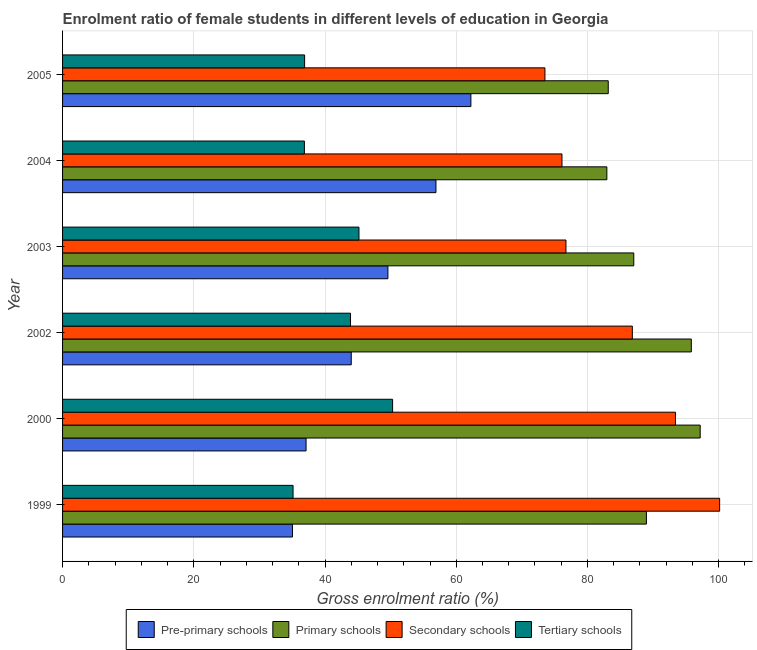How many different coloured bars are there?
Keep it short and to the point. 4. Are the number of bars per tick equal to the number of legend labels?
Make the answer very short. Yes. Are the number of bars on each tick of the Y-axis equal?
Make the answer very short. Yes. How many bars are there on the 4th tick from the top?
Give a very brief answer. 4. How many bars are there on the 3rd tick from the bottom?
Your response must be concise. 4. What is the label of the 2nd group of bars from the top?
Provide a short and direct response. 2004. In how many cases, is the number of bars for a given year not equal to the number of legend labels?
Keep it short and to the point. 0. What is the gross enrolment ratio(male) in pre-primary schools in 2004?
Make the answer very short. 56.91. Across all years, what is the maximum gross enrolment ratio(male) in tertiary schools?
Make the answer very short. 50.3. Across all years, what is the minimum gross enrolment ratio(male) in pre-primary schools?
Ensure brevity in your answer.  35.04. In which year was the gross enrolment ratio(male) in tertiary schools minimum?
Your response must be concise. 1999. What is the total gross enrolment ratio(male) in pre-primary schools in the graph?
Offer a very short reply. 284.87. What is the difference between the gross enrolment ratio(male) in primary schools in 2004 and that in 2005?
Your response must be concise. -0.21. What is the difference between the gross enrolment ratio(male) in primary schools in 2002 and the gross enrolment ratio(male) in tertiary schools in 2004?
Provide a succinct answer. 58.97. What is the average gross enrolment ratio(male) in tertiary schools per year?
Your response must be concise. 41.37. In the year 1999, what is the difference between the gross enrolment ratio(male) in secondary schools and gross enrolment ratio(male) in primary schools?
Keep it short and to the point. 11.16. What is the ratio of the gross enrolment ratio(male) in pre-primary schools in 1999 to that in 2003?
Offer a very short reply. 0.71. Is the gross enrolment ratio(male) in tertiary schools in 1999 less than that in 2004?
Make the answer very short. Yes. Is the difference between the gross enrolment ratio(male) in pre-primary schools in 2002 and 2003 greater than the difference between the gross enrolment ratio(male) in tertiary schools in 2002 and 2003?
Give a very brief answer. No. What is the difference between the highest and the second highest gross enrolment ratio(male) in primary schools?
Ensure brevity in your answer.  1.35. What is the difference between the highest and the lowest gross enrolment ratio(male) in secondary schools?
Your answer should be very brief. 26.63. In how many years, is the gross enrolment ratio(male) in pre-primary schools greater than the average gross enrolment ratio(male) in pre-primary schools taken over all years?
Offer a terse response. 3. Is the sum of the gross enrolment ratio(male) in pre-primary schools in 2002 and 2004 greater than the maximum gross enrolment ratio(male) in tertiary schools across all years?
Your answer should be very brief. Yes. Is it the case that in every year, the sum of the gross enrolment ratio(male) in pre-primary schools and gross enrolment ratio(male) in secondary schools is greater than the sum of gross enrolment ratio(male) in tertiary schools and gross enrolment ratio(male) in primary schools?
Offer a terse response. Yes. What does the 3rd bar from the top in 2003 represents?
Give a very brief answer. Primary schools. What does the 2nd bar from the bottom in 2004 represents?
Offer a terse response. Primary schools. Is it the case that in every year, the sum of the gross enrolment ratio(male) in pre-primary schools and gross enrolment ratio(male) in primary schools is greater than the gross enrolment ratio(male) in secondary schools?
Your answer should be very brief. Yes. Does the graph contain grids?
Make the answer very short. Yes. How many legend labels are there?
Keep it short and to the point. 4. How are the legend labels stacked?
Keep it short and to the point. Horizontal. What is the title of the graph?
Provide a short and direct response. Enrolment ratio of female students in different levels of education in Georgia. Does "Services" appear as one of the legend labels in the graph?
Ensure brevity in your answer.  No. What is the label or title of the Y-axis?
Make the answer very short. Year. What is the Gross enrolment ratio (%) in Pre-primary schools in 1999?
Provide a succinct answer. 35.04. What is the Gross enrolment ratio (%) in Primary schools in 1999?
Offer a terse response. 88.98. What is the Gross enrolment ratio (%) of Secondary schools in 1999?
Provide a short and direct response. 100.14. What is the Gross enrolment ratio (%) in Tertiary schools in 1999?
Offer a terse response. 35.13. What is the Gross enrolment ratio (%) of Pre-primary schools in 2000?
Provide a short and direct response. 37.11. What is the Gross enrolment ratio (%) of Primary schools in 2000?
Provide a short and direct response. 97.18. What is the Gross enrolment ratio (%) in Secondary schools in 2000?
Offer a very short reply. 93.41. What is the Gross enrolment ratio (%) of Tertiary schools in 2000?
Your response must be concise. 50.3. What is the Gross enrolment ratio (%) in Pre-primary schools in 2002?
Your response must be concise. 44. What is the Gross enrolment ratio (%) in Primary schools in 2002?
Your response must be concise. 95.83. What is the Gross enrolment ratio (%) of Secondary schools in 2002?
Make the answer very short. 86.84. What is the Gross enrolment ratio (%) of Tertiary schools in 2002?
Your answer should be very brief. 43.88. What is the Gross enrolment ratio (%) in Pre-primary schools in 2003?
Keep it short and to the point. 49.58. What is the Gross enrolment ratio (%) in Primary schools in 2003?
Offer a terse response. 87.06. What is the Gross enrolment ratio (%) of Secondary schools in 2003?
Your answer should be compact. 76.72. What is the Gross enrolment ratio (%) in Tertiary schools in 2003?
Offer a very short reply. 45.17. What is the Gross enrolment ratio (%) in Pre-primary schools in 2004?
Make the answer very short. 56.91. What is the Gross enrolment ratio (%) in Primary schools in 2004?
Provide a succinct answer. 82.95. What is the Gross enrolment ratio (%) in Secondary schools in 2004?
Make the answer very short. 76.11. What is the Gross enrolment ratio (%) in Tertiary schools in 2004?
Your answer should be very brief. 36.86. What is the Gross enrolment ratio (%) in Pre-primary schools in 2005?
Your answer should be very brief. 62.23. What is the Gross enrolment ratio (%) of Primary schools in 2005?
Make the answer very short. 83.17. What is the Gross enrolment ratio (%) of Secondary schools in 2005?
Offer a very short reply. 73.52. What is the Gross enrolment ratio (%) in Tertiary schools in 2005?
Your response must be concise. 36.89. Across all years, what is the maximum Gross enrolment ratio (%) in Pre-primary schools?
Offer a very short reply. 62.23. Across all years, what is the maximum Gross enrolment ratio (%) of Primary schools?
Provide a succinct answer. 97.18. Across all years, what is the maximum Gross enrolment ratio (%) of Secondary schools?
Keep it short and to the point. 100.14. Across all years, what is the maximum Gross enrolment ratio (%) of Tertiary schools?
Provide a succinct answer. 50.3. Across all years, what is the minimum Gross enrolment ratio (%) of Pre-primary schools?
Keep it short and to the point. 35.04. Across all years, what is the minimum Gross enrolment ratio (%) of Primary schools?
Make the answer very short. 82.95. Across all years, what is the minimum Gross enrolment ratio (%) in Secondary schools?
Provide a short and direct response. 73.52. Across all years, what is the minimum Gross enrolment ratio (%) of Tertiary schools?
Offer a very short reply. 35.13. What is the total Gross enrolment ratio (%) of Pre-primary schools in the graph?
Your response must be concise. 284.87. What is the total Gross enrolment ratio (%) of Primary schools in the graph?
Your answer should be very brief. 535.16. What is the total Gross enrolment ratio (%) in Secondary schools in the graph?
Your answer should be very brief. 506.74. What is the total Gross enrolment ratio (%) of Tertiary schools in the graph?
Keep it short and to the point. 248.23. What is the difference between the Gross enrolment ratio (%) in Pre-primary schools in 1999 and that in 2000?
Ensure brevity in your answer.  -2.07. What is the difference between the Gross enrolment ratio (%) in Primary schools in 1999 and that in 2000?
Ensure brevity in your answer.  -8.2. What is the difference between the Gross enrolment ratio (%) of Secondary schools in 1999 and that in 2000?
Offer a terse response. 6.73. What is the difference between the Gross enrolment ratio (%) in Tertiary schools in 1999 and that in 2000?
Offer a terse response. -15.17. What is the difference between the Gross enrolment ratio (%) in Pre-primary schools in 1999 and that in 2002?
Keep it short and to the point. -8.96. What is the difference between the Gross enrolment ratio (%) in Primary schools in 1999 and that in 2002?
Provide a short and direct response. -6.84. What is the difference between the Gross enrolment ratio (%) in Secondary schools in 1999 and that in 2002?
Offer a terse response. 13.3. What is the difference between the Gross enrolment ratio (%) of Tertiary schools in 1999 and that in 2002?
Your answer should be compact. -8.76. What is the difference between the Gross enrolment ratio (%) in Pre-primary schools in 1999 and that in 2003?
Your answer should be very brief. -14.55. What is the difference between the Gross enrolment ratio (%) in Primary schools in 1999 and that in 2003?
Provide a succinct answer. 1.92. What is the difference between the Gross enrolment ratio (%) of Secondary schools in 1999 and that in 2003?
Make the answer very short. 23.42. What is the difference between the Gross enrolment ratio (%) in Tertiary schools in 1999 and that in 2003?
Your answer should be very brief. -10.04. What is the difference between the Gross enrolment ratio (%) of Pre-primary schools in 1999 and that in 2004?
Provide a succinct answer. -21.87. What is the difference between the Gross enrolment ratio (%) of Primary schools in 1999 and that in 2004?
Your answer should be compact. 6.03. What is the difference between the Gross enrolment ratio (%) in Secondary schools in 1999 and that in 2004?
Provide a succinct answer. 24.03. What is the difference between the Gross enrolment ratio (%) of Tertiary schools in 1999 and that in 2004?
Ensure brevity in your answer.  -1.73. What is the difference between the Gross enrolment ratio (%) in Pre-primary schools in 1999 and that in 2005?
Ensure brevity in your answer.  -27.19. What is the difference between the Gross enrolment ratio (%) of Primary schools in 1999 and that in 2005?
Your answer should be compact. 5.82. What is the difference between the Gross enrolment ratio (%) in Secondary schools in 1999 and that in 2005?
Make the answer very short. 26.63. What is the difference between the Gross enrolment ratio (%) of Tertiary schools in 1999 and that in 2005?
Provide a short and direct response. -1.76. What is the difference between the Gross enrolment ratio (%) in Pre-primary schools in 2000 and that in 2002?
Provide a succinct answer. -6.89. What is the difference between the Gross enrolment ratio (%) in Primary schools in 2000 and that in 2002?
Give a very brief answer. 1.35. What is the difference between the Gross enrolment ratio (%) in Secondary schools in 2000 and that in 2002?
Offer a terse response. 6.57. What is the difference between the Gross enrolment ratio (%) in Tertiary schools in 2000 and that in 2002?
Your answer should be very brief. 6.41. What is the difference between the Gross enrolment ratio (%) of Pre-primary schools in 2000 and that in 2003?
Your answer should be very brief. -12.47. What is the difference between the Gross enrolment ratio (%) in Primary schools in 2000 and that in 2003?
Offer a very short reply. 10.12. What is the difference between the Gross enrolment ratio (%) of Secondary schools in 2000 and that in 2003?
Give a very brief answer. 16.69. What is the difference between the Gross enrolment ratio (%) of Tertiary schools in 2000 and that in 2003?
Provide a succinct answer. 5.12. What is the difference between the Gross enrolment ratio (%) of Pre-primary schools in 2000 and that in 2004?
Ensure brevity in your answer.  -19.8. What is the difference between the Gross enrolment ratio (%) in Primary schools in 2000 and that in 2004?
Make the answer very short. 14.22. What is the difference between the Gross enrolment ratio (%) in Secondary schools in 2000 and that in 2004?
Your response must be concise. 17.3. What is the difference between the Gross enrolment ratio (%) in Tertiary schools in 2000 and that in 2004?
Offer a terse response. 13.44. What is the difference between the Gross enrolment ratio (%) of Pre-primary schools in 2000 and that in 2005?
Offer a very short reply. -25.12. What is the difference between the Gross enrolment ratio (%) in Primary schools in 2000 and that in 2005?
Make the answer very short. 14.01. What is the difference between the Gross enrolment ratio (%) of Secondary schools in 2000 and that in 2005?
Keep it short and to the point. 19.89. What is the difference between the Gross enrolment ratio (%) in Tertiary schools in 2000 and that in 2005?
Offer a very short reply. 13.41. What is the difference between the Gross enrolment ratio (%) of Pre-primary schools in 2002 and that in 2003?
Your answer should be compact. -5.59. What is the difference between the Gross enrolment ratio (%) of Primary schools in 2002 and that in 2003?
Provide a succinct answer. 8.77. What is the difference between the Gross enrolment ratio (%) in Secondary schools in 2002 and that in 2003?
Ensure brevity in your answer.  10.12. What is the difference between the Gross enrolment ratio (%) of Tertiary schools in 2002 and that in 2003?
Provide a short and direct response. -1.29. What is the difference between the Gross enrolment ratio (%) in Pre-primary schools in 2002 and that in 2004?
Your answer should be compact. -12.91. What is the difference between the Gross enrolment ratio (%) in Primary schools in 2002 and that in 2004?
Offer a very short reply. 12.87. What is the difference between the Gross enrolment ratio (%) in Secondary schools in 2002 and that in 2004?
Offer a terse response. 10.73. What is the difference between the Gross enrolment ratio (%) of Tertiary schools in 2002 and that in 2004?
Offer a very short reply. 7.03. What is the difference between the Gross enrolment ratio (%) in Pre-primary schools in 2002 and that in 2005?
Your answer should be compact. -18.24. What is the difference between the Gross enrolment ratio (%) of Primary schools in 2002 and that in 2005?
Make the answer very short. 12.66. What is the difference between the Gross enrolment ratio (%) of Secondary schools in 2002 and that in 2005?
Offer a terse response. 13.32. What is the difference between the Gross enrolment ratio (%) of Tertiary schools in 2002 and that in 2005?
Your answer should be very brief. 6.99. What is the difference between the Gross enrolment ratio (%) of Pre-primary schools in 2003 and that in 2004?
Ensure brevity in your answer.  -7.32. What is the difference between the Gross enrolment ratio (%) of Primary schools in 2003 and that in 2004?
Your answer should be very brief. 4.1. What is the difference between the Gross enrolment ratio (%) of Secondary schools in 2003 and that in 2004?
Offer a terse response. 0.61. What is the difference between the Gross enrolment ratio (%) of Tertiary schools in 2003 and that in 2004?
Offer a very short reply. 8.32. What is the difference between the Gross enrolment ratio (%) of Pre-primary schools in 2003 and that in 2005?
Make the answer very short. -12.65. What is the difference between the Gross enrolment ratio (%) of Primary schools in 2003 and that in 2005?
Keep it short and to the point. 3.89. What is the difference between the Gross enrolment ratio (%) in Secondary schools in 2003 and that in 2005?
Provide a succinct answer. 3.2. What is the difference between the Gross enrolment ratio (%) of Tertiary schools in 2003 and that in 2005?
Offer a terse response. 8.28. What is the difference between the Gross enrolment ratio (%) of Pre-primary schools in 2004 and that in 2005?
Your response must be concise. -5.33. What is the difference between the Gross enrolment ratio (%) in Primary schools in 2004 and that in 2005?
Provide a short and direct response. -0.21. What is the difference between the Gross enrolment ratio (%) in Secondary schools in 2004 and that in 2005?
Your response must be concise. 2.6. What is the difference between the Gross enrolment ratio (%) in Tertiary schools in 2004 and that in 2005?
Give a very brief answer. -0.03. What is the difference between the Gross enrolment ratio (%) in Pre-primary schools in 1999 and the Gross enrolment ratio (%) in Primary schools in 2000?
Ensure brevity in your answer.  -62.14. What is the difference between the Gross enrolment ratio (%) in Pre-primary schools in 1999 and the Gross enrolment ratio (%) in Secondary schools in 2000?
Keep it short and to the point. -58.37. What is the difference between the Gross enrolment ratio (%) of Pre-primary schools in 1999 and the Gross enrolment ratio (%) of Tertiary schools in 2000?
Provide a short and direct response. -15.26. What is the difference between the Gross enrolment ratio (%) of Primary schools in 1999 and the Gross enrolment ratio (%) of Secondary schools in 2000?
Your response must be concise. -4.43. What is the difference between the Gross enrolment ratio (%) in Primary schools in 1999 and the Gross enrolment ratio (%) in Tertiary schools in 2000?
Give a very brief answer. 38.68. What is the difference between the Gross enrolment ratio (%) of Secondary schools in 1999 and the Gross enrolment ratio (%) of Tertiary schools in 2000?
Your answer should be compact. 49.84. What is the difference between the Gross enrolment ratio (%) of Pre-primary schools in 1999 and the Gross enrolment ratio (%) of Primary schools in 2002?
Your answer should be very brief. -60.79. What is the difference between the Gross enrolment ratio (%) of Pre-primary schools in 1999 and the Gross enrolment ratio (%) of Secondary schools in 2002?
Give a very brief answer. -51.8. What is the difference between the Gross enrolment ratio (%) in Pre-primary schools in 1999 and the Gross enrolment ratio (%) in Tertiary schools in 2002?
Give a very brief answer. -8.85. What is the difference between the Gross enrolment ratio (%) of Primary schools in 1999 and the Gross enrolment ratio (%) of Secondary schools in 2002?
Make the answer very short. 2.14. What is the difference between the Gross enrolment ratio (%) of Primary schools in 1999 and the Gross enrolment ratio (%) of Tertiary schools in 2002?
Keep it short and to the point. 45.1. What is the difference between the Gross enrolment ratio (%) in Secondary schools in 1999 and the Gross enrolment ratio (%) in Tertiary schools in 2002?
Your answer should be very brief. 56.26. What is the difference between the Gross enrolment ratio (%) in Pre-primary schools in 1999 and the Gross enrolment ratio (%) in Primary schools in 2003?
Make the answer very short. -52.02. What is the difference between the Gross enrolment ratio (%) in Pre-primary schools in 1999 and the Gross enrolment ratio (%) in Secondary schools in 2003?
Offer a very short reply. -41.68. What is the difference between the Gross enrolment ratio (%) in Pre-primary schools in 1999 and the Gross enrolment ratio (%) in Tertiary schools in 2003?
Your response must be concise. -10.14. What is the difference between the Gross enrolment ratio (%) in Primary schools in 1999 and the Gross enrolment ratio (%) in Secondary schools in 2003?
Your answer should be very brief. 12.26. What is the difference between the Gross enrolment ratio (%) in Primary schools in 1999 and the Gross enrolment ratio (%) in Tertiary schools in 2003?
Give a very brief answer. 43.81. What is the difference between the Gross enrolment ratio (%) in Secondary schools in 1999 and the Gross enrolment ratio (%) in Tertiary schools in 2003?
Your response must be concise. 54.97. What is the difference between the Gross enrolment ratio (%) in Pre-primary schools in 1999 and the Gross enrolment ratio (%) in Primary schools in 2004?
Offer a very short reply. -47.92. What is the difference between the Gross enrolment ratio (%) of Pre-primary schools in 1999 and the Gross enrolment ratio (%) of Secondary schools in 2004?
Give a very brief answer. -41.07. What is the difference between the Gross enrolment ratio (%) of Pre-primary schools in 1999 and the Gross enrolment ratio (%) of Tertiary schools in 2004?
Ensure brevity in your answer.  -1.82. What is the difference between the Gross enrolment ratio (%) of Primary schools in 1999 and the Gross enrolment ratio (%) of Secondary schools in 2004?
Your answer should be very brief. 12.87. What is the difference between the Gross enrolment ratio (%) of Primary schools in 1999 and the Gross enrolment ratio (%) of Tertiary schools in 2004?
Your response must be concise. 52.12. What is the difference between the Gross enrolment ratio (%) in Secondary schools in 1999 and the Gross enrolment ratio (%) in Tertiary schools in 2004?
Provide a short and direct response. 63.29. What is the difference between the Gross enrolment ratio (%) in Pre-primary schools in 1999 and the Gross enrolment ratio (%) in Primary schools in 2005?
Your answer should be compact. -48.13. What is the difference between the Gross enrolment ratio (%) in Pre-primary schools in 1999 and the Gross enrolment ratio (%) in Secondary schools in 2005?
Provide a short and direct response. -38.48. What is the difference between the Gross enrolment ratio (%) in Pre-primary schools in 1999 and the Gross enrolment ratio (%) in Tertiary schools in 2005?
Make the answer very short. -1.85. What is the difference between the Gross enrolment ratio (%) in Primary schools in 1999 and the Gross enrolment ratio (%) in Secondary schools in 2005?
Offer a very short reply. 15.46. What is the difference between the Gross enrolment ratio (%) in Primary schools in 1999 and the Gross enrolment ratio (%) in Tertiary schools in 2005?
Provide a short and direct response. 52.09. What is the difference between the Gross enrolment ratio (%) of Secondary schools in 1999 and the Gross enrolment ratio (%) of Tertiary schools in 2005?
Your response must be concise. 63.25. What is the difference between the Gross enrolment ratio (%) of Pre-primary schools in 2000 and the Gross enrolment ratio (%) of Primary schools in 2002?
Make the answer very short. -58.71. What is the difference between the Gross enrolment ratio (%) in Pre-primary schools in 2000 and the Gross enrolment ratio (%) in Secondary schools in 2002?
Provide a succinct answer. -49.73. What is the difference between the Gross enrolment ratio (%) of Pre-primary schools in 2000 and the Gross enrolment ratio (%) of Tertiary schools in 2002?
Offer a very short reply. -6.77. What is the difference between the Gross enrolment ratio (%) of Primary schools in 2000 and the Gross enrolment ratio (%) of Secondary schools in 2002?
Ensure brevity in your answer.  10.34. What is the difference between the Gross enrolment ratio (%) in Primary schools in 2000 and the Gross enrolment ratio (%) in Tertiary schools in 2002?
Ensure brevity in your answer.  53.29. What is the difference between the Gross enrolment ratio (%) of Secondary schools in 2000 and the Gross enrolment ratio (%) of Tertiary schools in 2002?
Offer a very short reply. 49.53. What is the difference between the Gross enrolment ratio (%) of Pre-primary schools in 2000 and the Gross enrolment ratio (%) of Primary schools in 2003?
Provide a short and direct response. -49.95. What is the difference between the Gross enrolment ratio (%) of Pre-primary schools in 2000 and the Gross enrolment ratio (%) of Secondary schools in 2003?
Provide a succinct answer. -39.61. What is the difference between the Gross enrolment ratio (%) in Pre-primary schools in 2000 and the Gross enrolment ratio (%) in Tertiary schools in 2003?
Keep it short and to the point. -8.06. What is the difference between the Gross enrolment ratio (%) of Primary schools in 2000 and the Gross enrolment ratio (%) of Secondary schools in 2003?
Provide a short and direct response. 20.46. What is the difference between the Gross enrolment ratio (%) of Primary schools in 2000 and the Gross enrolment ratio (%) of Tertiary schools in 2003?
Give a very brief answer. 52.01. What is the difference between the Gross enrolment ratio (%) in Secondary schools in 2000 and the Gross enrolment ratio (%) in Tertiary schools in 2003?
Offer a very short reply. 48.24. What is the difference between the Gross enrolment ratio (%) of Pre-primary schools in 2000 and the Gross enrolment ratio (%) of Primary schools in 2004?
Offer a terse response. -45.84. What is the difference between the Gross enrolment ratio (%) in Pre-primary schools in 2000 and the Gross enrolment ratio (%) in Secondary schools in 2004?
Ensure brevity in your answer.  -39. What is the difference between the Gross enrolment ratio (%) of Pre-primary schools in 2000 and the Gross enrolment ratio (%) of Tertiary schools in 2004?
Keep it short and to the point. 0.26. What is the difference between the Gross enrolment ratio (%) in Primary schools in 2000 and the Gross enrolment ratio (%) in Secondary schools in 2004?
Make the answer very short. 21.07. What is the difference between the Gross enrolment ratio (%) in Primary schools in 2000 and the Gross enrolment ratio (%) in Tertiary schools in 2004?
Provide a succinct answer. 60.32. What is the difference between the Gross enrolment ratio (%) of Secondary schools in 2000 and the Gross enrolment ratio (%) of Tertiary schools in 2004?
Your answer should be compact. 56.56. What is the difference between the Gross enrolment ratio (%) of Pre-primary schools in 2000 and the Gross enrolment ratio (%) of Primary schools in 2005?
Keep it short and to the point. -46.05. What is the difference between the Gross enrolment ratio (%) in Pre-primary schools in 2000 and the Gross enrolment ratio (%) in Secondary schools in 2005?
Offer a very short reply. -36.41. What is the difference between the Gross enrolment ratio (%) in Pre-primary schools in 2000 and the Gross enrolment ratio (%) in Tertiary schools in 2005?
Offer a very short reply. 0.22. What is the difference between the Gross enrolment ratio (%) in Primary schools in 2000 and the Gross enrolment ratio (%) in Secondary schools in 2005?
Make the answer very short. 23.66. What is the difference between the Gross enrolment ratio (%) in Primary schools in 2000 and the Gross enrolment ratio (%) in Tertiary schools in 2005?
Make the answer very short. 60.29. What is the difference between the Gross enrolment ratio (%) of Secondary schools in 2000 and the Gross enrolment ratio (%) of Tertiary schools in 2005?
Make the answer very short. 56.52. What is the difference between the Gross enrolment ratio (%) of Pre-primary schools in 2002 and the Gross enrolment ratio (%) of Primary schools in 2003?
Offer a very short reply. -43.06. What is the difference between the Gross enrolment ratio (%) of Pre-primary schools in 2002 and the Gross enrolment ratio (%) of Secondary schools in 2003?
Provide a short and direct response. -32.72. What is the difference between the Gross enrolment ratio (%) in Pre-primary schools in 2002 and the Gross enrolment ratio (%) in Tertiary schools in 2003?
Make the answer very short. -1.18. What is the difference between the Gross enrolment ratio (%) of Primary schools in 2002 and the Gross enrolment ratio (%) of Secondary schools in 2003?
Your answer should be compact. 19.1. What is the difference between the Gross enrolment ratio (%) in Primary schools in 2002 and the Gross enrolment ratio (%) in Tertiary schools in 2003?
Your answer should be compact. 50.65. What is the difference between the Gross enrolment ratio (%) of Secondary schools in 2002 and the Gross enrolment ratio (%) of Tertiary schools in 2003?
Give a very brief answer. 41.67. What is the difference between the Gross enrolment ratio (%) of Pre-primary schools in 2002 and the Gross enrolment ratio (%) of Primary schools in 2004?
Ensure brevity in your answer.  -38.96. What is the difference between the Gross enrolment ratio (%) in Pre-primary schools in 2002 and the Gross enrolment ratio (%) in Secondary schools in 2004?
Offer a very short reply. -32.12. What is the difference between the Gross enrolment ratio (%) in Pre-primary schools in 2002 and the Gross enrolment ratio (%) in Tertiary schools in 2004?
Offer a terse response. 7.14. What is the difference between the Gross enrolment ratio (%) in Primary schools in 2002 and the Gross enrolment ratio (%) in Secondary schools in 2004?
Your answer should be very brief. 19.71. What is the difference between the Gross enrolment ratio (%) of Primary schools in 2002 and the Gross enrolment ratio (%) of Tertiary schools in 2004?
Provide a short and direct response. 58.97. What is the difference between the Gross enrolment ratio (%) of Secondary schools in 2002 and the Gross enrolment ratio (%) of Tertiary schools in 2004?
Your answer should be very brief. 49.98. What is the difference between the Gross enrolment ratio (%) of Pre-primary schools in 2002 and the Gross enrolment ratio (%) of Primary schools in 2005?
Provide a succinct answer. -39.17. What is the difference between the Gross enrolment ratio (%) of Pre-primary schools in 2002 and the Gross enrolment ratio (%) of Secondary schools in 2005?
Provide a short and direct response. -29.52. What is the difference between the Gross enrolment ratio (%) of Pre-primary schools in 2002 and the Gross enrolment ratio (%) of Tertiary schools in 2005?
Provide a short and direct response. 7.11. What is the difference between the Gross enrolment ratio (%) in Primary schools in 2002 and the Gross enrolment ratio (%) in Secondary schools in 2005?
Offer a very short reply. 22.31. What is the difference between the Gross enrolment ratio (%) of Primary schools in 2002 and the Gross enrolment ratio (%) of Tertiary schools in 2005?
Give a very brief answer. 58.94. What is the difference between the Gross enrolment ratio (%) of Secondary schools in 2002 and the Gross enrolment ratio (%) of Tertiary schools in 2005?
Your response must be concise. 49.95. What is the difference between the Gross enrolment ratio (%) of Pre-primary schools in 2003 and the Gross enrolment ratio (%) of Primary schools in 2004?
Give a very brief answer. -33.37. What is the difference between the Gross enrolment ratio (%) of Pre-primary schools in 2003 and the Gross enrolment ratio (%) of Secondary schools in 2004?
Offer a terse response. -26.53. What is the difference between the Gross enrolment ratio (%) in Pre-primary schools in 2003 and the Gross enrolment ratio (%) in Tertiary schools in 2004?
Make the answer very short. 12.73. What is the difference between the Gross enrolment ratio (%) of Primary schools in 2003 and the Gross enrolment ratio (%) of Secondary schools in 2004?
Your answer should be compact. 10.94. What is the difference between the Gross enrolment ratio (%) of Primary schools in 2003 and the Gross enrolment ratio (%) of Tertiary schools in 2004?
Your answer should be very brief. 50.2. What is the difference between the Gross enrolment ratio (%) in Secondary schools in 2003 and the Gross enrolment ratio (%) in Tertiary schools in 2004?
Your answer should be compact. 39.86. What is the difference between the Gross enrolment ratio (%) in Pre-primary schools in 2003 and the Gross enrolment ratio (%) in Primary schools in 2005?
Offer a terse response. -33.58. What is the difference between the Gross enrolment ratio (%) in Pre-primary schools in 2003 and the Gross enrolment ratio (%) in Secondary schools in 2005?
Offer a very short reply. -23.93. What is the difference between the Gross enrolment ratio (%) in Pre-primary schools in 2003 and the Gross enrolment ratio (%) in Tertiary schools in 2005?
Your response must be concise. 12.69. What is the difference between the Gross enrolment ratio (%) in Primary schools in 2003 and the Gross enrolment ratio (%) in Secondary schools in 2005?
Ensure brevity in your answer.  13.54. What is the difference between the Gross enrolment ratio (%) of Primary schools in 2003 and the Gross enrolment ratio (%) of Tertiary schools in 2005?
Offer a terse response. 50.17. What is the difference between the Gross enrolment ratio (%) of Secondary schools in 2003 and the Gross enrolment ratio (%) of Tertiary schools in 2005?
Offer a very short reply. 39.83. What is the difference between the Gross enrolment ratio (%) in Pre-primary schools in 2004 and the Gross enrolment ratio (%) in Primary schools in 2005?
Your response must be concise. -26.26. What is the difference between the Gross enrolment ratio (%) of Pre-primary schools in 2004 and the Gross enrolment ratio (%) of Secondary schools in 2005?
Give a very brief answer. -16.61. What is the difference between the Gross enrolment ratio (%) in Pre-primary schools in 2004 and the Gross enrolment ratio (%) in Tertiary schools in 2005?
Provide a short and direct response. 20.02. What is the difference between the Gross enrolment ratio (%) in Primary schools in 2004 and the Gross enrolment ratio (%) in Secondary schools in 2005?
Provide a succinct answer. 9.44. What is the difference between the Gross enrolment ratio (%) in Primary schools in 2004 and the Gross enrolment ratio (%) in Tertiary schools in 2005?
Provide a succinct answer. 46.06. What is the difference between the Gross enrolment ratio (%) in Secondary schools in 2004 and the Gross enrolment ratio (%) in Tertiary schools in 2005?
Make the answer very short. 39.22. What is the average Gross enrolment ratio (%) of Pre-primary schools per year?
Make the answer very short. 47.48. What is the average Gross enrolment ratio (%) of Primary schools per year?
Your response must be concise. 89.19. What is the average Gross enrolment ratio (%) of Secondary schools per year?
Your response must be concise. 84.46. What is the average Gross enrolment ratio (%) of Tertiary schools per year?
Ensure brevity in your answer.  41.37. In the year 1999, what is the difference between the Gross enrolment ratio (%) in Pre-primary schools and Gross enrolment ratio (%) in Primary schools?
Your response must be concise. -53.94. In the year 1999, what is the difference between the Gross enrolment ratio (%) of Pre-primary schools and Gross enrolment ratio (%) of Secondary schools?
Your answer should be very brief. -65.1. In the year 1999, what is the difference between the Gross enrolment ratio (%) in Pre-primary schools and Gross enrolment ratio (%) in Tertiary schools?
Your answer should be compact. -0.09. In the year 1999, what is the difference between the Gross enrolment ratio (%) of Primary schools and Gross enrolment ratio (%) of Secondary schools?
Provide a short and direct response. -11.16. In the year 1999, what is the difference between the Gross enrolment ratio (%) in Primary schools and Gross enrolment ratio (%) in Tertiary schools?
Your response must be concise. 53.85. In the year 1999, what is the difference between the Gross enrolment ratio (%) of Secondary schools and Gross enrolment ratio (%) of Tertiary schools?
Provide a succinct answer. 65.01. In the year 2000, what is the difference between the Gross enrolment ratio (%) in Pre-primary schools and Gross enrolment ratio (%) in Primary schools?
Provide a short and direct response. -60.07. In the year 2000, what is the difference between the Gross enrolment ratio (%) of Pre-primary schools and Gross enrolment ratio (%) of Secondary schools?
Offer a very short reply. -56.3. In the year 2000, what is the difference between the Gross enrolment ratio (%) of Pre-primary schools and Gross enrolment ratio (%) of Tertiary schools?
Make the answer very short. -13.19. In the year 2000, what is the difference between the Gross enrolment ratio (%) in Primary schools and Gross enrolment ratio (%) in Secondary schools?
Offer a very short reply. 3.77. In the year 2000, what is the difference between the Gross enrolment ratio (%) of Primary schools and Gross enrolment ratio (%) of Tertiary schools?
Your answer should be compact. 46.88. In the year 2000, what is the difference between the Gross enrolment ratio (%) in Secondary schools and Gross enrolment ratio (%) in Tertiary schools?
Make the answer very short. 43.11. In the year 2002, what is the difference between the Gross enrolment ratio (%) in Pre-primary schools and Gross enrolment ratio (%) in Primary schools?
Make the answer very short. -51.83. In the year 2002, what is the difference between the Gross enrolment ratio (%) of Pre-primary schools and Gross enrolment ratio (%) of Secondary schools?
Ensure brevity in your answer.  -42.84. In the year 2002, what is the difference between the Gross enrolment ratio (%) in Pre-primary schools and Gross enrolment ratio (%) in Tertiary schools?
Provide a succinct answer. 0.11. In the year 2002, what is the difference between the Gross enrolment ratio (%) of Primary schools and Gross enrolment ratio (%) of Secondary schools?
Offer a very short reply. 8.99. In the year 2002, what is the difference between the Gross enrolment ratio (%) of Primary schools and Gross enrolment ratio (%) of Tertiary schools?
Ensure brevity in your answer.  51.94. In the year 2002, what is the difference between the Gross enrolment ratio (%) of Secondary schools and Gross enrolment ratio (%) of Tertiary schools?
Make the answer very short. 42.95. In the year 2003, what is the difference between the Gross enrolment ratio (%) in Pre-primary schools and Gross enrolment ratio (%) in Primary schools?
Ensure brevity in your answer.  -37.47. In the year 2003, what is the difference between the Gross enrolment ratio (%) in Pre-primary schools and Gross enrolment ratio (%) in Secondary schools?
Give a very brief answer. -27.14. In the year 2003, what is the difference between the Gross enrolment ratio (%) in Pre-primary schools and Gross enrolment ratio (%) in Tertiary schools?
Keep it short and to the point. 4.41. In the year 2003, what is the difference between the Gross enrolment ratio (%) in Primary schools and Gross enrolment ratio (%) in Secondary schools?
Provide a succinct answer. 10.34. In the year 2003, what is the difference between the Gross enrolment ratio (%) of Primary schools and Gross enrolment ratio (%) of Tertiary schools?
Make the answer very short. 41.88. In the year 2003, what is the difference between the Gross enrolment ratio (%) in Secondary schools and Gross enrolment ratio (%) in Tertiary schools?
Make the answer very short. 31.55. In the year 2004, what is the difference between the Gross enrolment ratio (%) in Pre-primary schools and Gross enrolment ratio (%) in Primary schools?
Make the answer very short. -26.05. In the year 2004, what is the difference between the Gross enrolment ratio (%) in Pre-primary schools and Gross enrolment ratio (%) in Secondary schools?
Ensure brevity in your answer.  -19.21. In the year 2004, what is the difference between the Gross enrolment ratio (%) in Pre-primary schools and Gross enrolment ratio (%) in Tertiary schools?
Provide a short and direct response. 20.05. In the year 2004, what is the difference between the Gross enrolment ratio (%) of Primary schools and Gross enrolment ratio (%) of Secondary schools?
Your answer should be very brief. 6.84. In the year 2004, what is the difference between the Gross enrolment ratio (%) of Primary schools and Gross enrolment ratio (%) of Tertiary schools?
Give a very brief answer. 46.1. In the year 2004, what is the difference between the Gross enrolment ratio (%) in Secondary schools and Gross enrolment ratio (%) in Tertiary schools?
Your answer should be compact. 39.26. In the year 2005, what is the difference between the Gross enrolment ratio (%) of Pre-primary schools and Gross enrolment ratio (%) of Primary schools?
Provide a short and direct response. -20.93. In the year 2005, what is the difference between the Gross enrolment ratio (%) of Pre-primary schools and Gross enrolment ratio (%) of Secondary schools?
Your response must be concise. -11.28. In the year 2005, what is the difference between the Gross enrolment ratio (%) of Pre-primary schools and Gross enrolment ratio (%) of Tertiary schools?
Make the answer very short. 25.34. In the year 2005, what is the difference between the Gross enrolment ratio (%) in Primary schools and Gross enrolment ratio (%) in Secondary schools?
Make the answer very short. 9.65. In the year 2005, what is the difference between the Gross enrolment ratio (%) in Primary schools and Gross enrolment ratio (%) in Tertiary schools?
Ensure brevity in your answer.  46.28. In the year 2005, what is the difference between the Gross enrolment ratio (%) of Secondary schools and Gross enrolment ratio (%) of Tertiary schools?
Provide a short and direct response. 36.63. What is the ratio of the Gross enrolment ratio (%) in Pre-primary schools in 1999 to that in 2000?
Your answer should be very brief. 0.94. What is the ratio of the Gross enrolment ratio (%) in Primary schools in 1999 to that in 2000?
Offer a terse response. 0.92. What is the ratio of the Gross enrolment ratio (%) of Secondary schools in 1999 to that in 2000?
Your answer should be very brief. 1.07. What is the ratio of the Gross enrolment ratio (%) in Tertiary schools in 1999 to that in 2000?
Offer a very short reply. 0.7. What is the ratio of the Gross enrolment ratio (%) of Pre-primary schools in 1999 to that in 2002?
Your answer should be compact. 0.8. What is the ratio of the Gross enrolment ratio (%) in Primary schools in 1999 to that in 2002?
Offer a terse response. 0.93. What is the ratio of the Gross enrolment ratio (%) in Secondary schools in 1999 to that in 2002?
Your answer should be compact. 1.15. What is the ratio of the Gross enrolment ratio (%) in Tertiary schools in 1999 to that in 2002?
Give a very brief answer. 0.8. What is the ratio of the Gross enrolment ratio (%) in Pre-primary schools in 1999 to that in 2003?
Your response must be concise. 0.71. What is the ratio of the Gross enrolment ratio (%) in Primary schools in 1999 to that in 2003?
Make the answer very short. 1.02. What is the ratio of the Gross enrolment ratio (%) in Secondary schools in 1999 to that in 2003?
Provide a succinct answer. 1.31. What is the ratio of the Gross enrolment ratio (%) of Tertiary schools in 1999 to that in 2003?
Ensure brevity in your answer.  0.78. What is the ratio of the Gross enrolment ratio (%) in Pre-primary schools in 1999 to that in 2004?
Keep it short and to the point. 0.62. What is the ratio of the Gross enrolment ratio (%) of Primary schools in 1999 to that in 2004?
Provide a short and direct response. 1.07. What is the ratio of the Gross enrolment ratio (%) of Secondary schools in 1999 to that in 2004?
Offer a very short reply. 1.32. What is the ratio of the Gross enrolment ratio (%) in Tertiary schools in 1999 to that in 2004?
Keep it short and to the point. 0.95. What is the ratio of the Gross enrolment ratio (%) of Pre-primary schools in 1999 to that in 2005?
Provide a succinct answer. 0.56. What is the ratio of the Gross enrolment ratio (%) in Primary schools in 1999 to that in 2005?
Your answer should be very brief. 1.07. What is the ratio of the Gross enrolment ratio (%) in Secondary schools in 1999 to that in 2005?
Your response must be concise. 1.36. What is the ratio of the Gross enrolment ratio (%) of Tertiary schools in 1999 to that in 2005?
Your response must be concise. 0.95. What is the ratio of the Gross enrolment ratio (%) of Pre-primary schools in 2000 to that in 2002?
Make the answer very short. 0.84. What is the ratio of the Gross enrolment ratio (%) in Primary schools in 2000 to that in 2002?
Provide a short and direct response. 1.01. What is the ratio of the Gross enrolment ratio (%) in Secondary schools in 2000 to that in 2002?
Provide a succinct answer. 1.08. What is the ratio of the Gross enrolment ratio (%) in Tertiary schools in 2000 to that in 2002?
Make the answer very short. 1.15. What is the ratio of the Gross enrolment ratio (%) of Pre-primary schools in 2000 to that in 2003?
Keep it short and to the point. 0.75. What is the ratio of the Gross enrolment ratio (%) of Primary schools in 2000 to that in 2003?
Provide a succinct answer. 1.12. What is the ratio of the Gross enrolment ratio (%) in Secondary schools in 2000 to that in 2003?
Your answer should be compact. 1.22. What is the ratio of the Gross enrolment ratio (%) in Tertiary schools in 2000 to that in 2003?
Make the answer very short. 1.11. What is the ratio of the Gross enrolment ratio (%) of Pre-primary schools in 2000 to that in 2004?
Your answer should be very brief. 0.65. What is the ratio of the Gross enrolment ratio (%) of Primary schools in 2000 to that in 2004?
Make the answer very short. 1.17. What is the ratio of the Gross enrolment ratio (%) in Secondary schools in 2000 to that in 2004?
Your answer should be very brief. 1.23. What is the ratio of the Gross enrolment ratio (%) in Tertiary schools in 2000 to that in 2004?
Your answer should be very brief. 1.36. What is the ratio of the Gross enrolment ratio (%) in Pre-primary schools in 2000 to that in 2005?
Your answer should be very brief. 0.6. What is the ratio of the Gross enrolment ratio (%) of Primary schools in 2000 to that in 2005?
Give a very brief answer. 1.17. What is the ratio of the Gross enrolment ratio (%) in Secondary schools in 2000 to that in 2005?
Give a very brief answer. 1.27. What is the ratio of the Gross enrolment ratio (%) in Tertiary schools in 2000 to that in 2005?
Your answer should be compact. 1.36. What is the ratio of the Gross enrolment ratio (%) of Pre-primary schools in 2002 to that in 2003?
Give a very brief answer. 0.89. What is the ratio of the Gross enrolment ratio (%) in Primary schools in 2002 to that in 2003?
Your answer should be compact. 1.1. What is the ratio of the Gross enrolment ratio (%) of Secondary schools in 2002 to that in 2003?
Provide a succinct answer. 1.13. What is the ratio of the Gross enrolment ratio (%) in Tertiary schools in 2002 to that in 2003?
Provide a succinct answer. 0.97. What is the ratio of the Gross enrolment ratio (%) of Pre-primary schools in 2002 to that in 2004?
Ensure brevity in your answer.  0.77. What is the ratio of the Gross enrolment ratio (%) in Primary schools in 2002 to that in 2004?
Give a very brief answer. 1.16. What is the ratio of the Gross enrolment ratio (%) of Secondary schools in 2002 to that in 2004?
Give a very brief answer. 1.14. What is the ratio of the Gross enrolment ratio (%) of Tertiary schools in 2002 to that in 2004?
Provide a succinct answer. 1.19. What is the ratio of the Gross enrolment ratio (%) of Pre-primary schools in 2002 to that in 2005?
Give a very brief answer. 0.71. What is the ratio of the Gross enrolment ratio (%) in Primary schools in 2002 to that in 2005?
Offer a terse response. 1.15. What is the ratio of the Gross enrolment ratio (%) of Secondary schools in 2002 to that in 2005?
Your response must be concise. 1.18. What is the ratio of the Gross enrolment ratio (%) in Tertiary schools in 2002 to that in 2005?
Ensure brevity in your answer.  1.19. What is the ratio of the Gross enrolment ratio (%) in Pre-primary schools in 2003 to that in 2004?
Give a very brief answer. 0.87. What is the ratio of the Gross enrolment ratio (%) in Primary schools in 2003 to that in 2004?
Your response must be concise. 1.05. What is the ratio of the Gross enrolment ratio (%) of Secondary schools in 2003 to that in 2004?
Your response must be concise. 1.01. What is the ratio of the Gross enrolment ratio (%) in Tertiary schools in 2003 to that in 2004?
Offer a very short reply. 1.23. What is the ratio of the Gross enrolment ratio (%) of Pre-primary schools in 2003 to that in 2005?
Your answer should be compact. 0.8. What is the ratio of the Gross enrolment ratio (%) in Primary schools in 2003 to that in 2005?
Offer a very short reply. 1.05. What is the ratio of the Gross enrolment ratio (%) in Secondary schools in 2003 to that in 2005?
Provide a succinct answer. 1.04. What is the ratio of the Gross enrolment ratio (%) in Tertiary schools in 2003 to that in 2005?
Your answer should be very brief. 1.22. What is the ratio of the Gross enrolment ratio (%) of Pre-primary schools in 2004 to that in 2005?
Provide a succinct answer. 0.91. What is the ratio of the Gross enrolment ratio (%) in Primary schools in 2004 to that in 2005?
Ensure brevity in your answer.  1. What is the ratio of the Gross enrolment ratio (%) in Secondary schools in 2004 to that in 2005?
Ensure brevity in your answer.  1.04. What is the difference between the highest and the second highest Gross enrolment ratio (%) in Pre-primary schools?
Offer a terse response. 5.33. What is the difference between the highest and the second highest Gross enrolment ratio (%) in Primary schools?
Make the answer very short. 1.35. What is the difference between the highest and the second highest Gross enrolment ratio (%) of Secondary schools?
Your response must be concise. 6.73. What is the difference between the highest and the second highest Gross enrolment ratio (%) of Tertiary schools?
Your answer should be compact. 5.12. What is the difference between the highest and the lowest Gross enrolment ratio (%) of Pre-primary schools?
Ensure brevity in your answer.  27.19. What is the difference between the highest and the lowest Gross enrolment ratio (%) in Primary schools?
Your response must be concise. 14.22. What is the difference between the highest and the lowest Gross enrolment ratio (%) in Secondary schools?
Give a very brief answer. 26.63. What is the difference between the highest and the lowest Gross enrolment ratio (%) of Tertiary schools?
Offer a terse response. 15.17. 